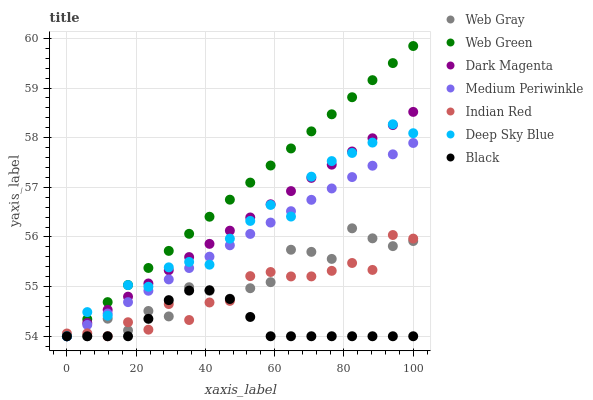Does Black have the minimum area under the curve?
Answer yes or no. Yes. Does Web Green have the maximum area under the curve?
Answer yes or no. Yes. Does Deep Sky Blue have the minimum area under the curve?
Answer yes or no. No. Does Deep Sky Blue have the maximum area under the curve?
Answer yes or no. No. Is Web Green the smoothest?
Answer yes or no. Yes. Is Web Gray the roughest?
Answer yes or no. Yes. Is Deep Sky Blue the smoothest?
Answer yes or no. No. Is Deep Sky Blue the roughest?
Answer yes or no. No. Does Web Gray have the lowest value?
Answer yes or no. Yes. Does Web Green have the highest value?
Answer yes or no. Yes. Does Deep Sky Blue have the highest value?
Answer yes or no. No. Does Deep Sky Blue intersect Black?
Answer yes or no. Yes. Is Deep Sky Blue less than Black?
Answer yes or no. No. Is Deep Sky Blue greater than Black?
Answer yes or no. No. 